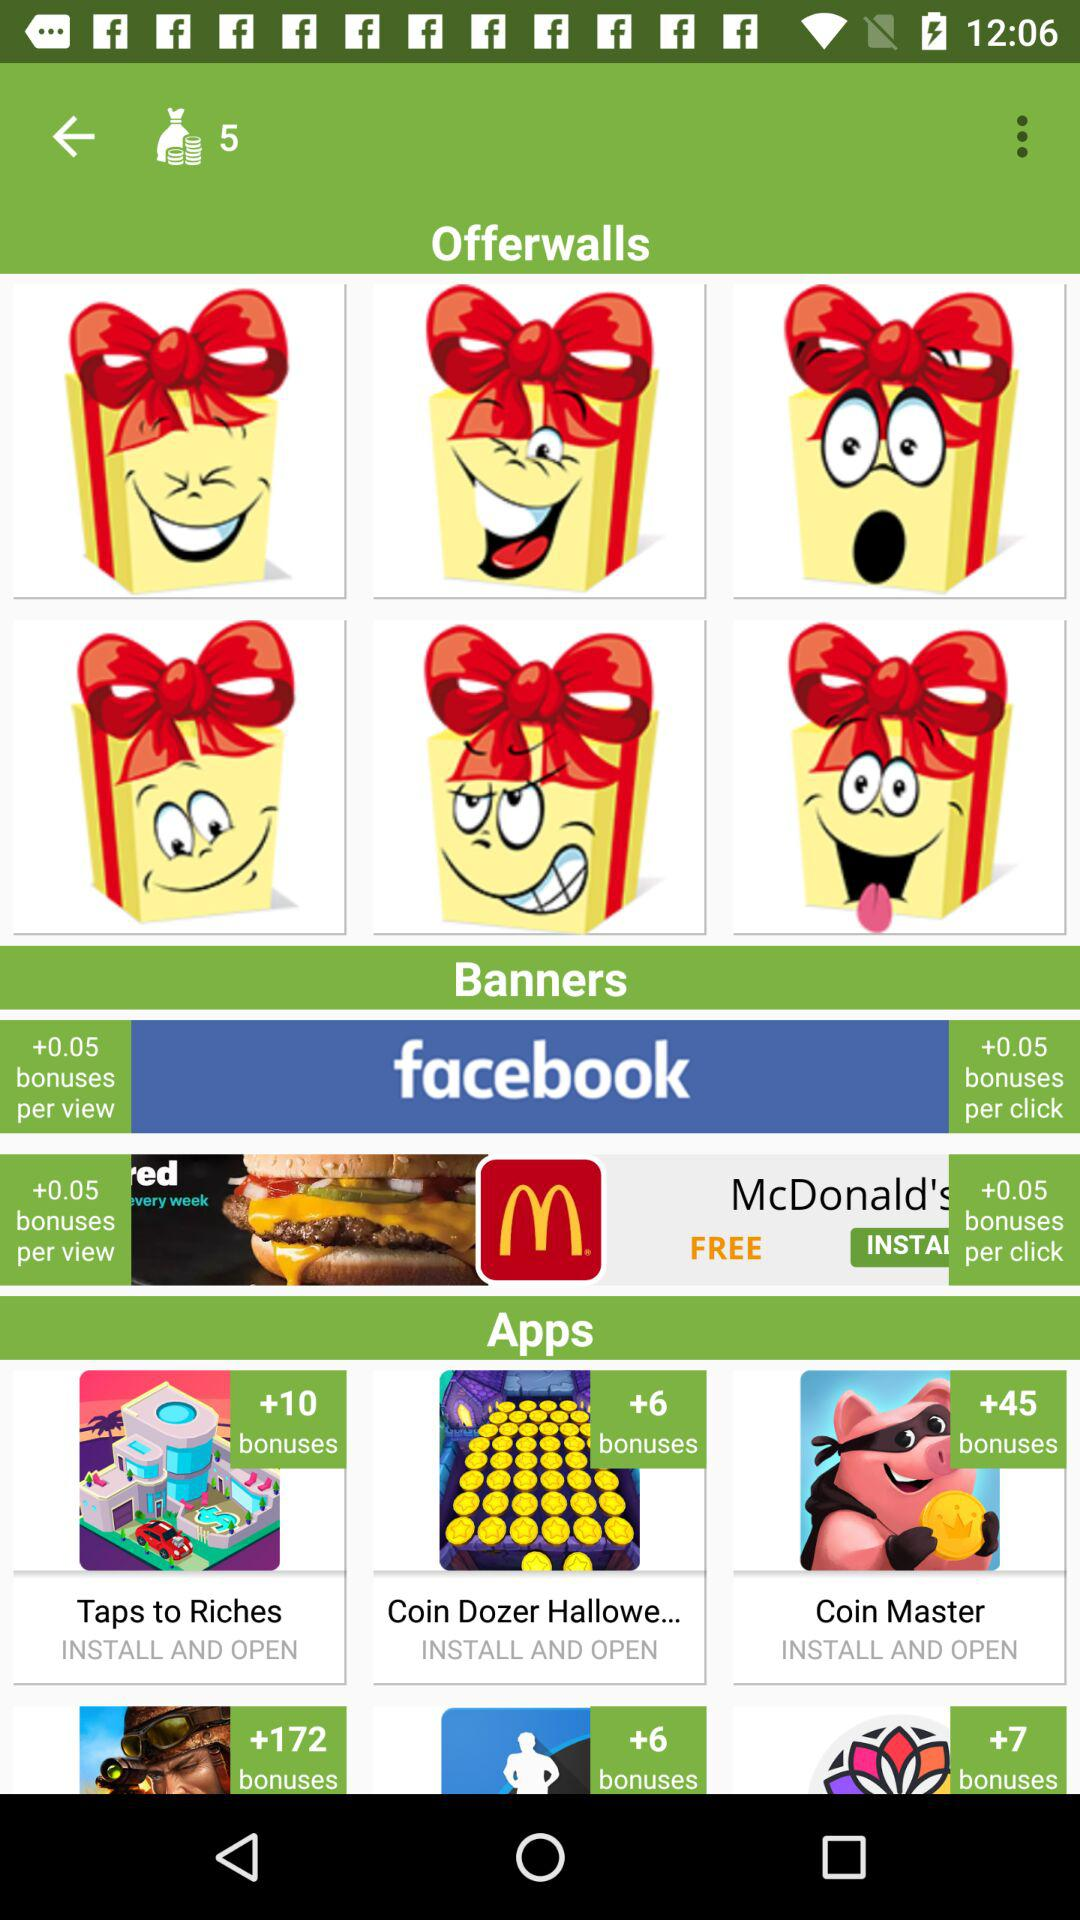What bonus will be offered on "Coin Master"? The offered bonus will be +45. 